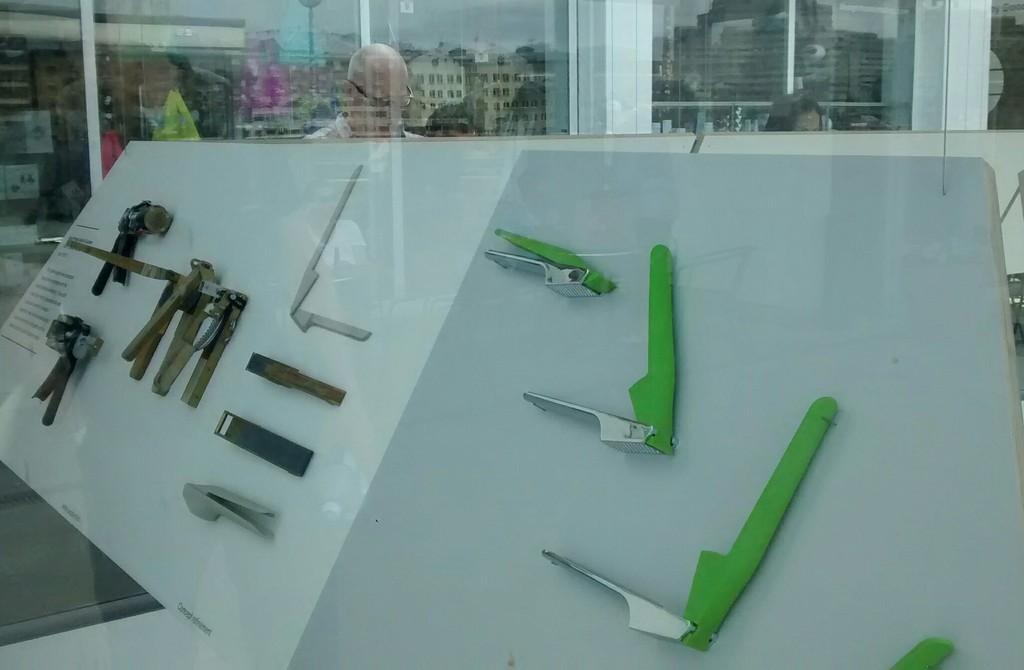What objects can be seen in the image related to work or construction? There are tools in the image. What is on the board that is visible in the image? There is a paper on a board in the image. Who is present in the image? There is a group of people standing in the image. What can be seen in the image that is a reflection of the surroundings? There is a reflection of buildings and the sky in the image. Can you see any clouds in the image? There are no clouds mentioned in the provided facts, and the image does not show any clouds. Is there a ship visible in the image? There is no mention of a ship in the provided facts, and the image does not show any ship. 